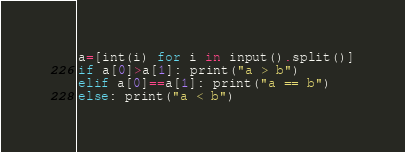<code> <loc_0><loc_0><loc_500><loc_500><_Python_>a=[int(i) for i in input().split()]
if a[0]>a[1]: print("a > b")
elif a[0]==a[1]: print("a == b")
else: print("a < b")



</code> 